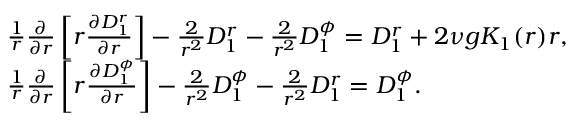<formula> <loc_0><loc_0><loc_500><loc_500>\begin{array} { r l } & { \frac { 1 } { r } \frac { \partial } { \partial r } \left [ r \frac { \partial D _ { 1 } ^ { r } } { \partial r } \right ] - \frac { 2 } { r ^ { 2 } } D _ { 1 } ^ { r } - \frac { 2 } { r ^ { 2 } } D _ { 1 } ^ { \phi } = D _ { 1 } ^ { r } + 2 \nu g K _ { 1 } ( r ) r , } \\ & { \frac { 1 } { r } \frac { \partial } { \partial r } \left [ r \frac { \partial D _ { 1 } ^ { \phi } } { \partial r } \right ] - \frac { 2 } { r ^ { 2 } } D _ { 1 } ^ { \phi } - \frac { 2 } { r ^ { 2 } } D _ { 1 } ^ { r } = D _ { 1 } ^ { \phi } . } \end{array}</formula> 